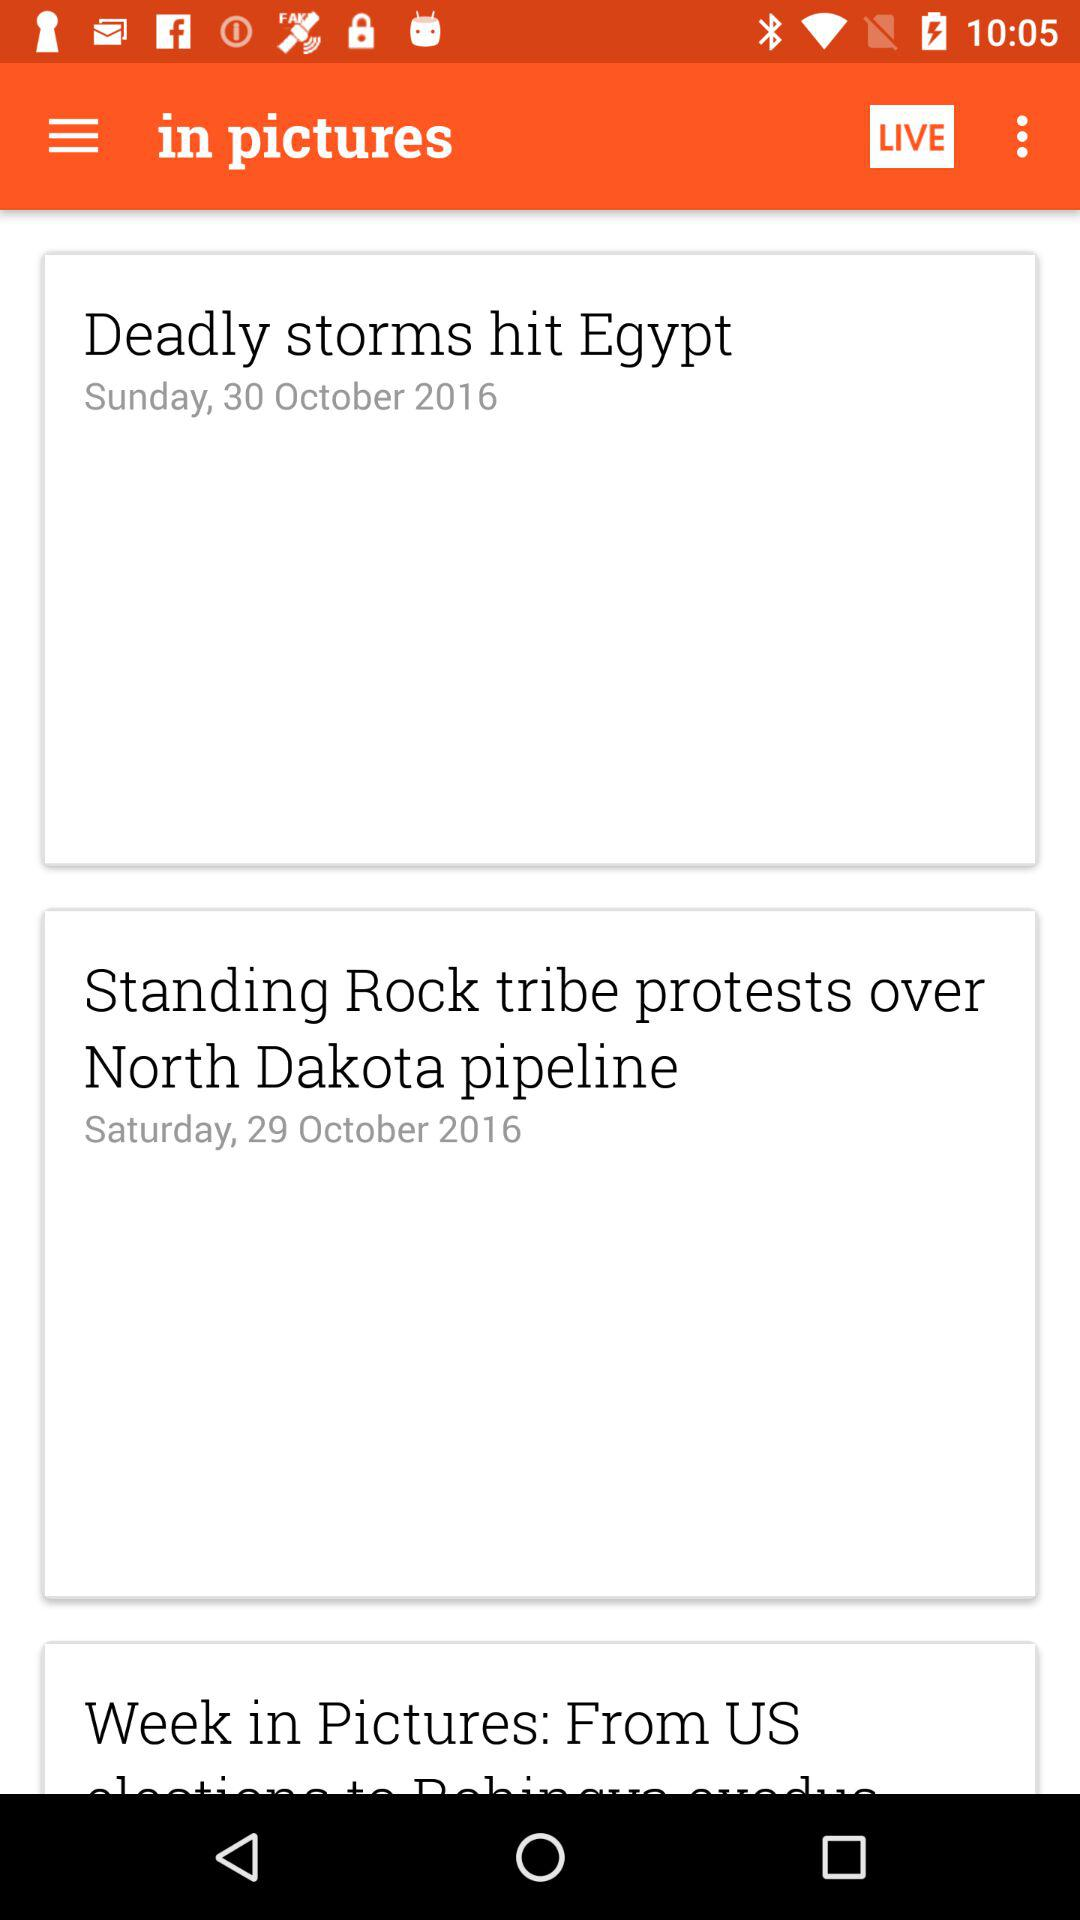What was the headline on October 30, 2016? The headline is "Deadly storms hit Egypt". 